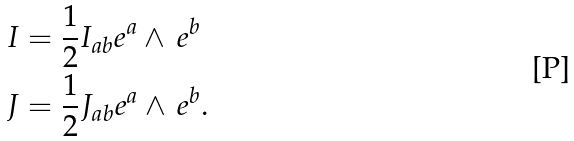Convert formula to latex. <formula><loc_0><loc_0><loc_500><loc_500>I & = \frac { 1 } { 2 } I _ { a b } e ^ { a } \wedge \, e ^ { b } \\ J & = \frac { 1 } { 2 } J _ { a b } e ^ { a } \wedge \, e ^ { b } .</formula> 